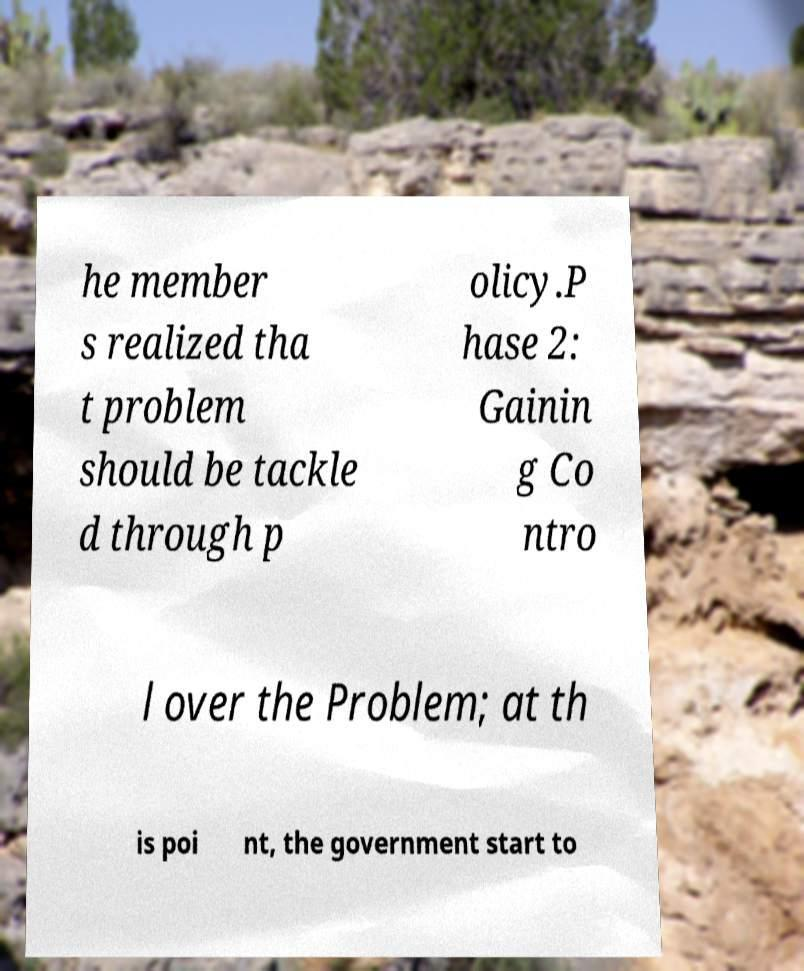Please identify and transcribe the text found in this image. he member s realized tha t problem should be tackle d through p olicy.P hase 2: Gainin g Co ntro l over the Problem; at th is poi nt, the government start to 